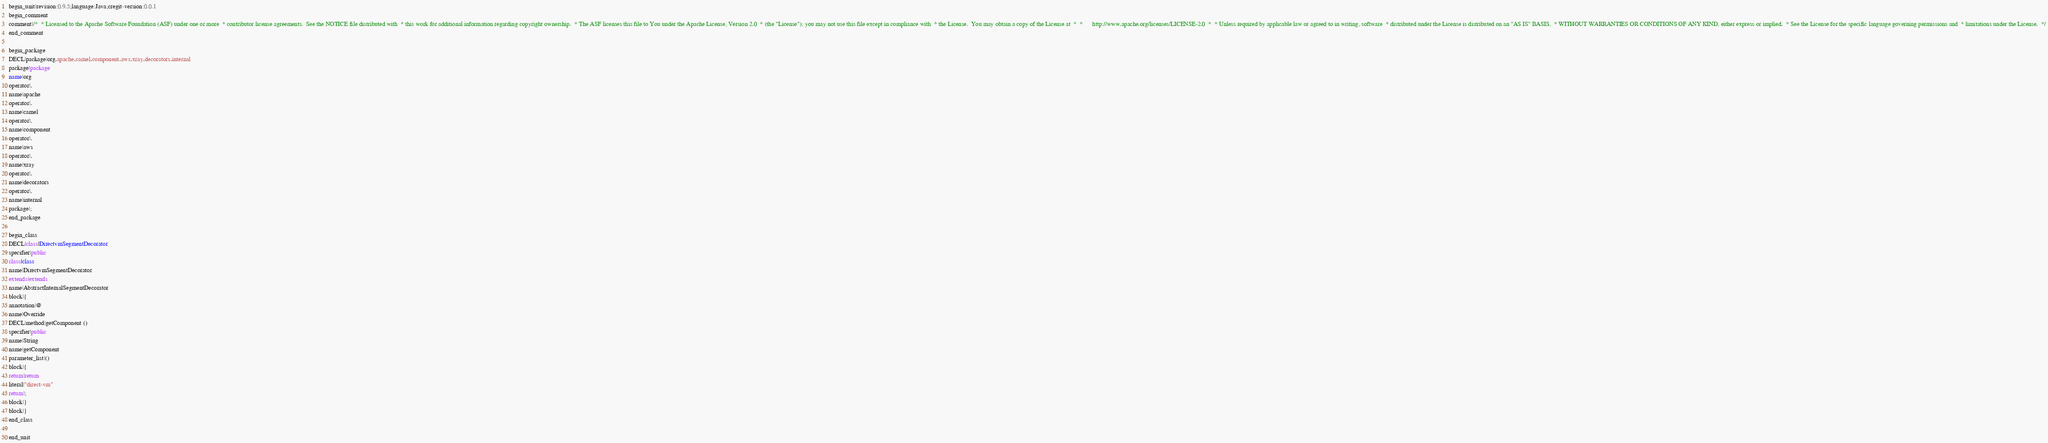<code> <loc_0><loc_0><loc_500><loc_500><_Java_>begin_unit|revision:0.9.5;language:Java;cregit-version:0.0.1
begin_comment
comment|/*  * Licensed to the Apache Software Foundation (ASF) under one or more  * contributor license agreements.  See the NOTICE file distributed with  * this work for additional information regarding copyright ownership.  * The ASF licenses this file to You under the Apache License, Version 2.0  * (the "License"); you may not use this file except in compliance with  * the License.  You may obtain a copy of the License at  *  *      http://www.apache.org/licenses/LICENSE-2.0  *  * Unless required by applicable law or agreed to in writing, software  * distributed under the License is distributed on an "AS IS" BASIS,  * WITHOUT WARRANTIES OR CONDITIONS OF ANY KIND, either express or implied.  * See the License for the specific language governing permissions and  * limitations under the License.  */
end_comment

begin_package
DECL|package|org.apache.camel.component.aws.xray.decorators.internal
package|package
name|org
operator|.
name|apache
operator|.
name|camel
operator|.
name|component
operator|.
name|aws
operator|.
name|xray
operator|.
name|decorators
operator|.
name|internal
package|;
end_package

begin_class
DECL|class|DirectvmSegmentDecorator
specifier|public
class|class
name|DirectvmSegmentDecorator
extends|extends
name|AbstractInternalSegmentDecorator
block|{
annotation|@
name|Override
DECL|method|getComponent ()
specifier|public
name|String
name|getComponent
parameter_list|()
block|{
return|return
literal|"direct-vm"
return|;
block|}
block|}
end_class

end_unit

</code> 